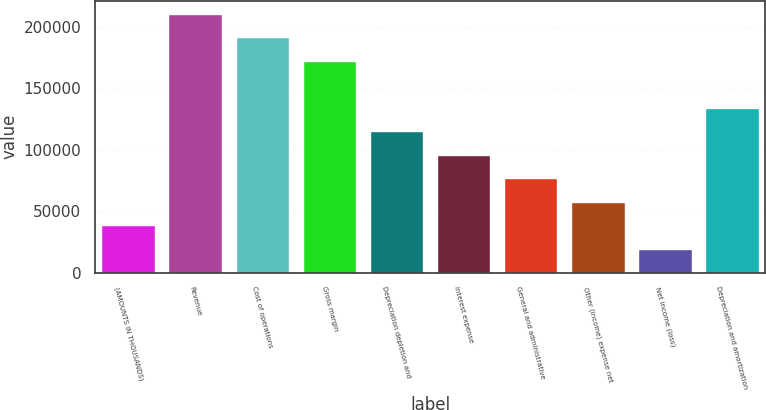Convert chart to OTSL. <chart><loc_0><loc_0><loc_500><loc_500><bar_chart><fcel>(AMOUNTS IN THOUSANDS)<fcel>Revenue<fcel>Cost of operations<fcel>Gross margin<fcel>Depreciation depletion and<fcel>Interest expense<fcel>General and administrative<fcel>Other (income) expense net<fcel>Net income (loss)<fcel>Depreciation and amortization<nl><fcel>38367<fcel>210748<fcel>191595<fcel>172442<fcel>114981<fcel>95827.5<fcel>76674<fcel>57520.5<fcel>19213.5<fcel>134134<nl></chart> 